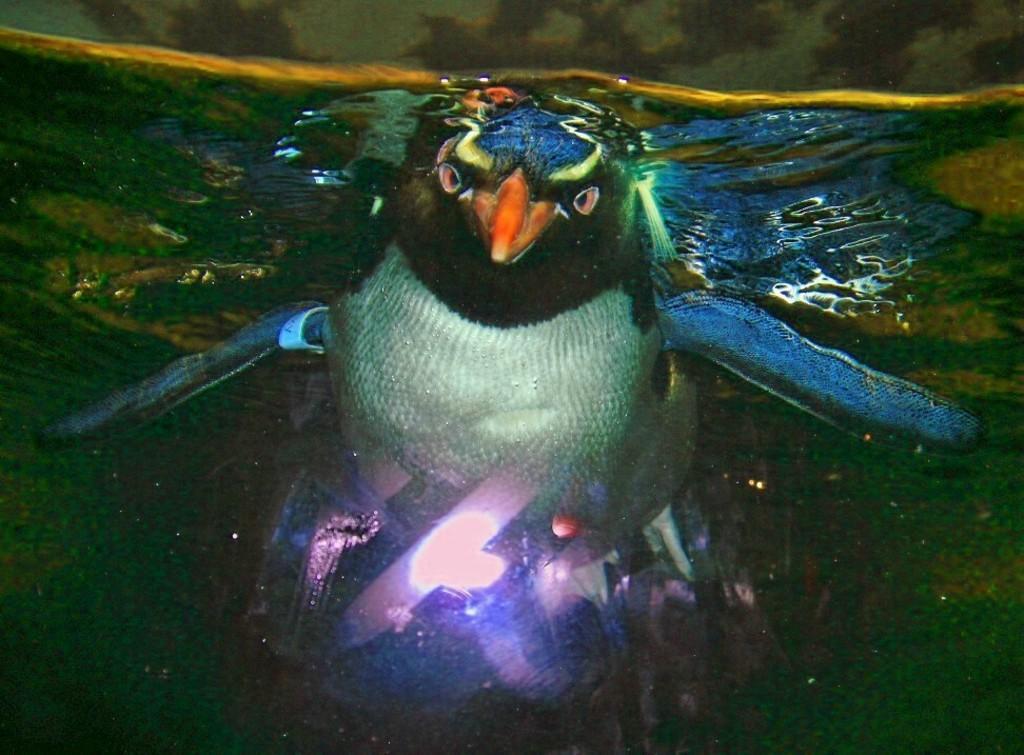Can you describe this image briefly? In this picture we can see the painting photograph of the blue and white color eagle under the water. 